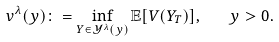Convert formula to latex. <formula><loc_0><loc_0><loc_500><loc_500>v ^ { \lambda } ( y ) \colon = \inf _ { Y \in \mathcal { Y } ^ { \lambda } ( y ) } \mathbb { E } [ V ( Y _ { T } ) ] , \quad y > 0 .</formula> 